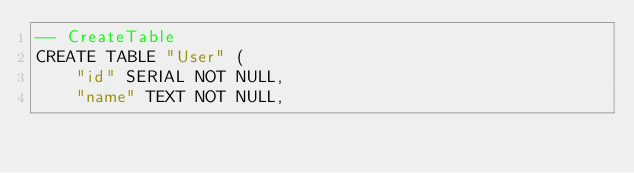<code> <loc_0><loc_0><loc_500><loc_500><_SQL_>-- CreateTable
CREATE TABLE "User" (
    "id" SERIAL NOT NULL,
    "name" TEXT NOT NULL,
</code> 